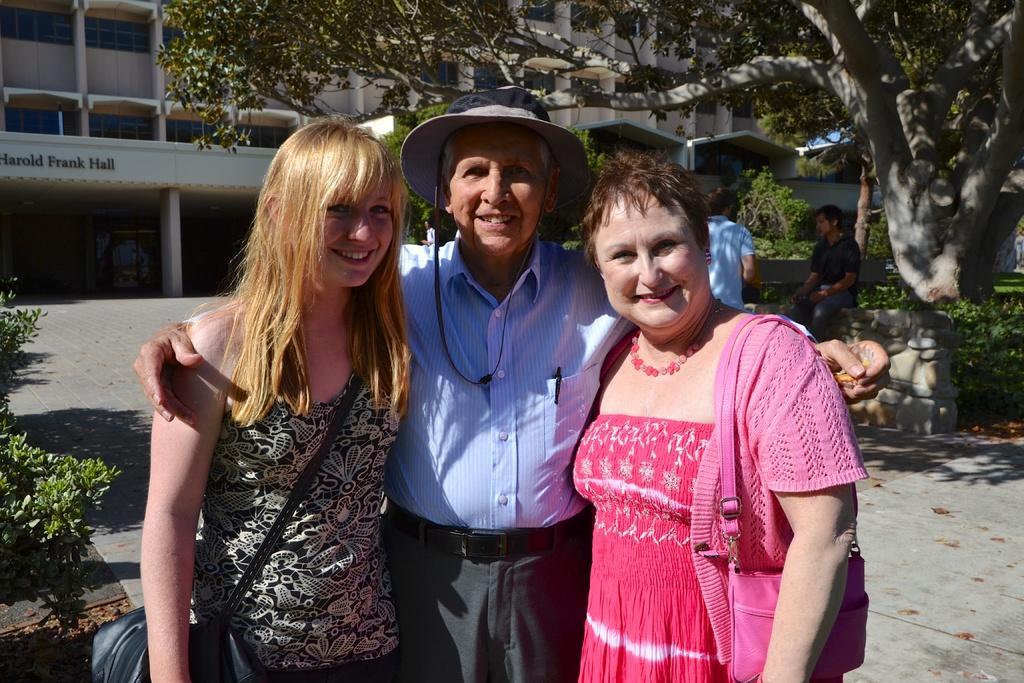Could you give a brief overview of what you see in this image? In this image we can see three persons smiling. Behind the persons we can see the rock wall, persons, plants and a tree. In the background, we can see a building. On the left side, we can see a plant. 